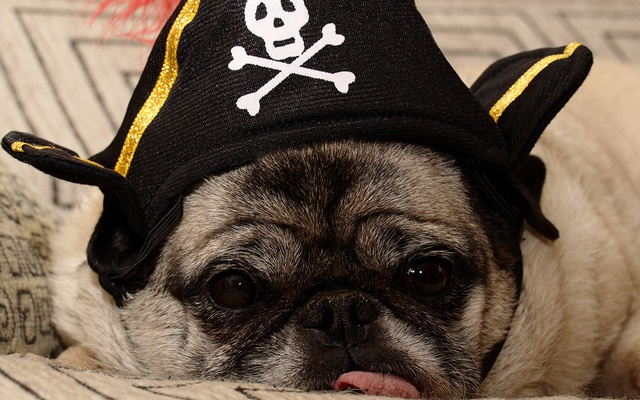Describe the objects in this image and their specific colors. I can see dog in tan, black, and gray tones and couch in tan tones in this image. 